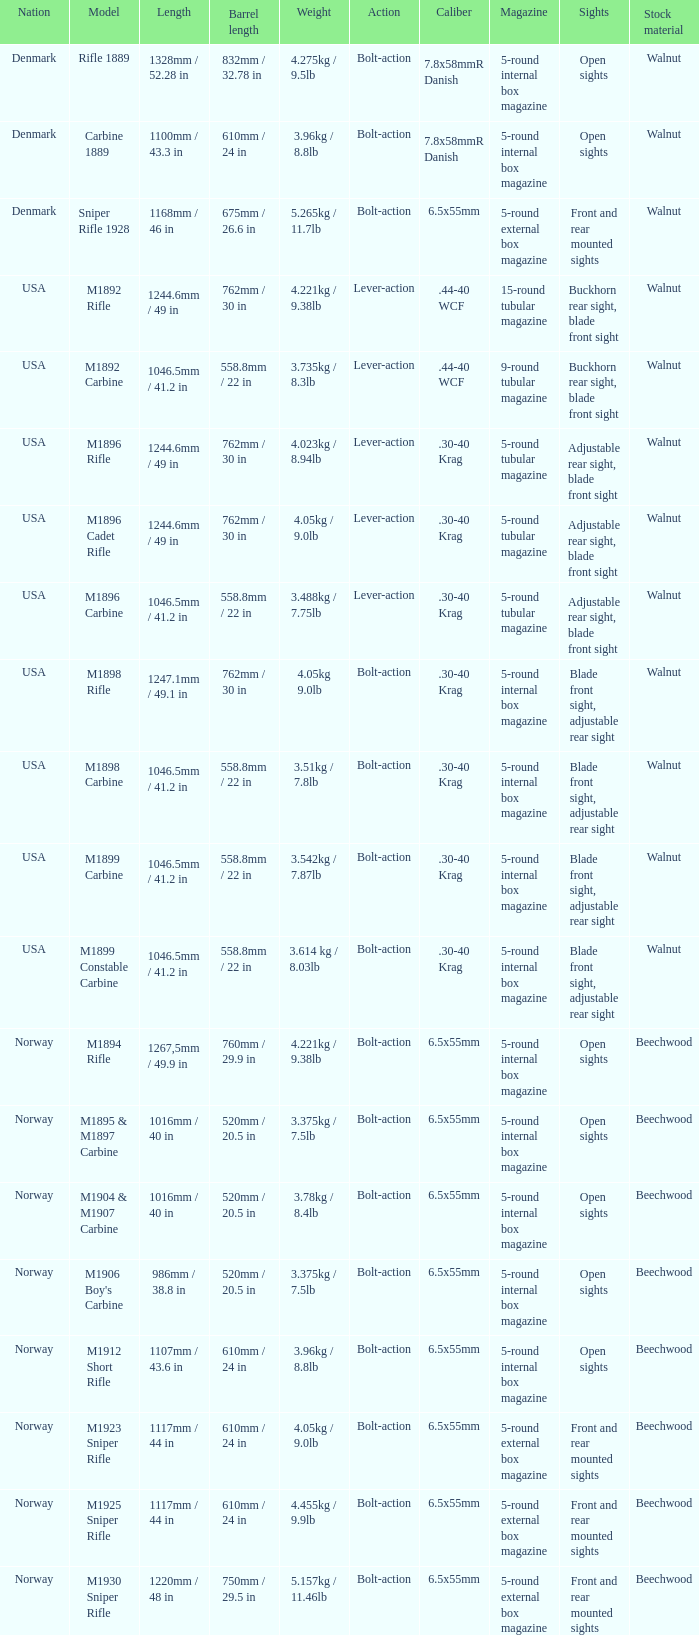What is Length, when Barrel Length is 750mm / 29.5 in? 1220mm / 48 in. 